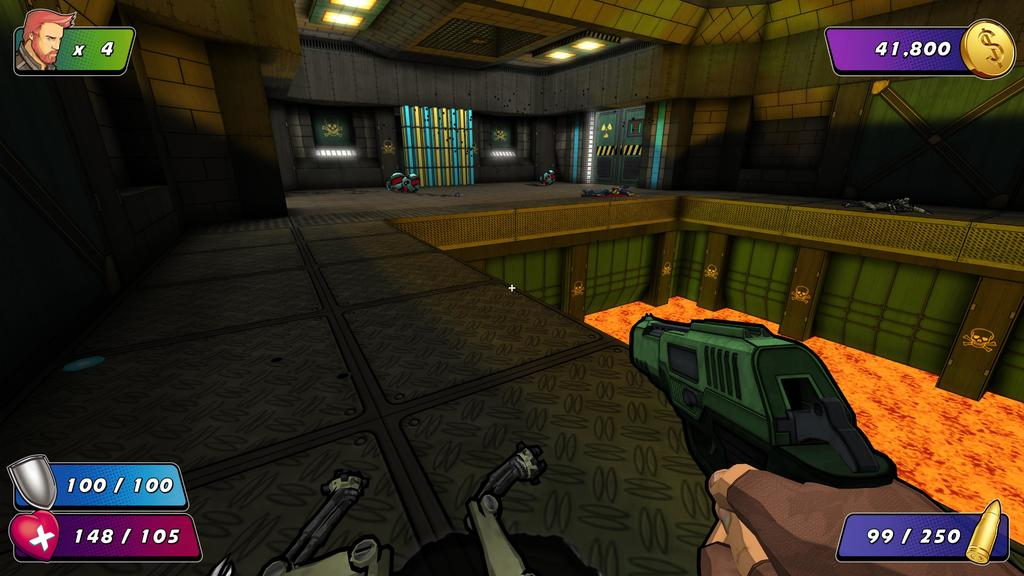What type of picture is the image? The image is an animated picture. What can be seen in the image besides the cartoon images? There are lights visible in the image. What type of structure is present in the image? There is a wall and a ceiling in the image. What is the person in the image holding? A person's hands are holding a gun in the image. What type of lipstick is the person wearing in the image? There is no lipstick or person's lips visible in the image; the person is holding a gun. How much debt is the person in the image in? There is no information about the person's financial situation in the image. 